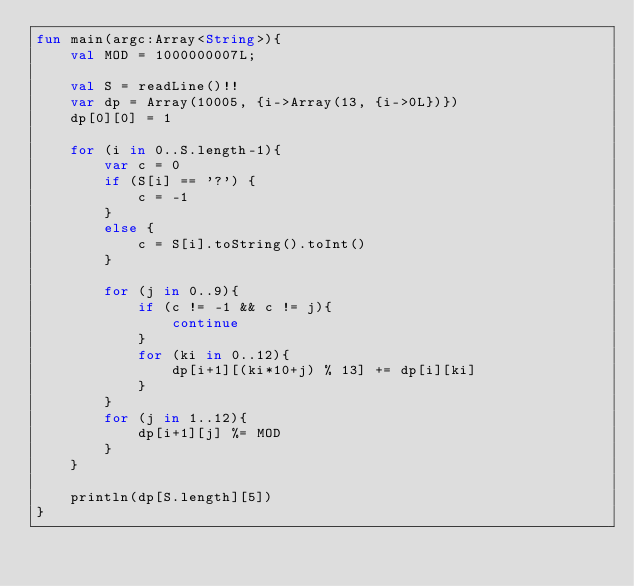<code> <loc_0><loc_0><loc_500><loc_500><_Kotlin_>fun main(argc:Array<String>){
    val MOD = 1000000007L;

    val S = readLine()!!
    var dp = Array(10005, {i->Array(13, {i->0L})})
    dp[0][0] = 1

    for (i in 0..S.length-1){
        var c = 0
        if (S[i] == '?') {
            c = -1
        }
        else {
            c = S[i].toString().toInt()
        }

        for (j in 0..9){
            if (c != -1 && c != j){
                continue
            }
            for (ki in 0..12){
                dp[i+1][(ki*10+j) % 13] += dp[i][ki]
            }
        }
        for (j in 1..12){
            dp[i+1][j] %= MOD
        }
    }
  
    println(dp[S.length][5])
}</code> 